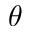Convert formula to latex. <formula><loc_0><loc_0><loc_500><loc_500>\theta</formula> 